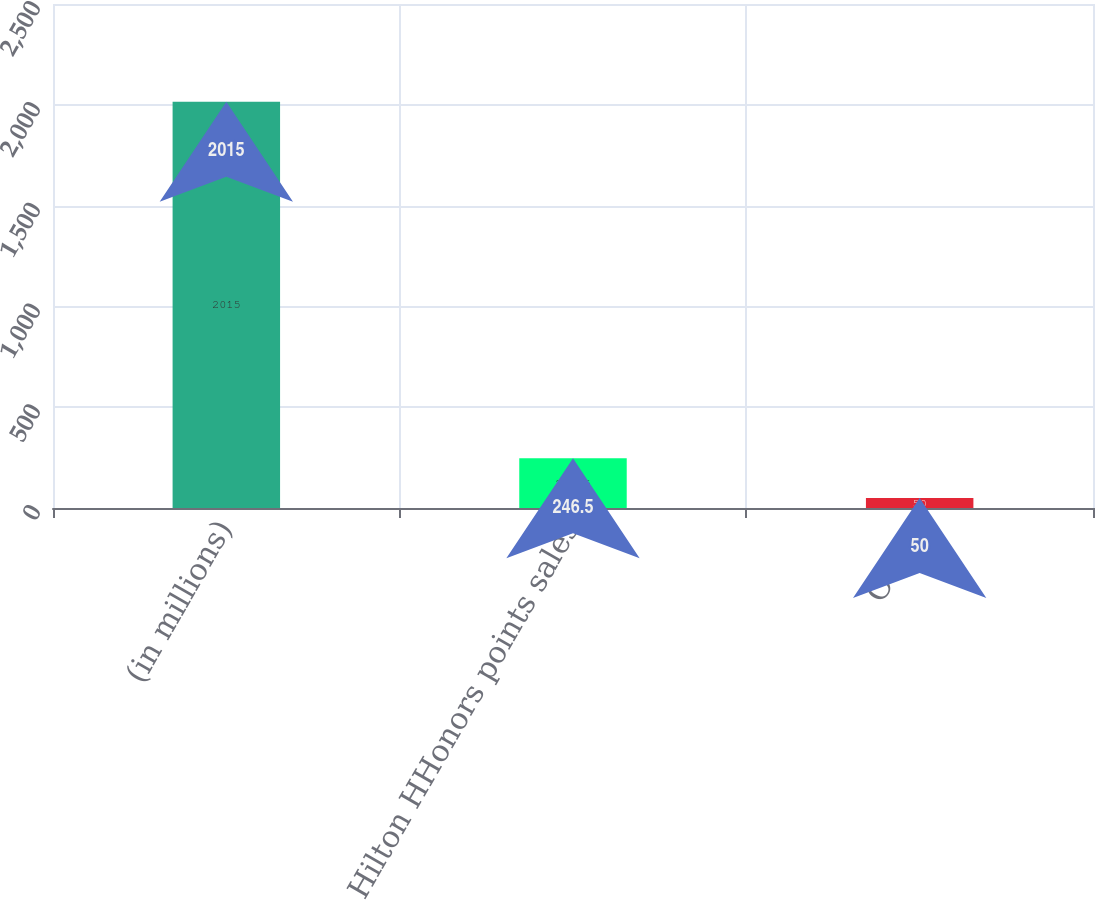Convert chart to OTSL. <chart><loc_0><loc_0><loc_500><loc_500><bar_chart><fcel>(in millions)<fcel>Hilton HHonors points sales<fcel>Other<nl><fcel>2015<fcel>246.5<fcel>50<nl></chart> 